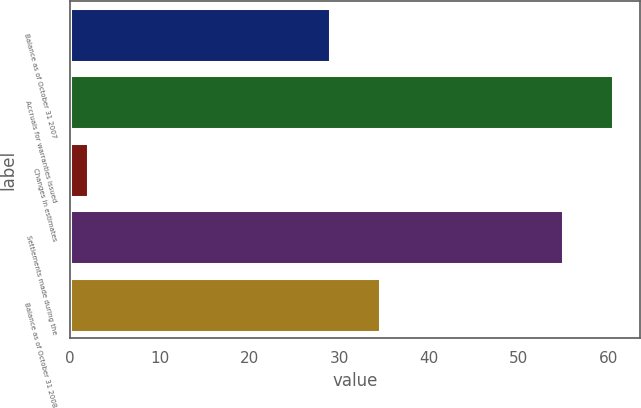Convert chart. <chart><loc_0><loc_0><loc_500><loc_500><bar_chart><fcel>Balance as of October 31 2007<fcel>Accruals for warranties issued<fcel>Changes in estimates<fcel>Settlements made during the<fcel>Balance as of October 31 2008<nl><fcel>29<fcel>60.5<fcel>2<fcel>55<fcel>34.5<nl></chart> 